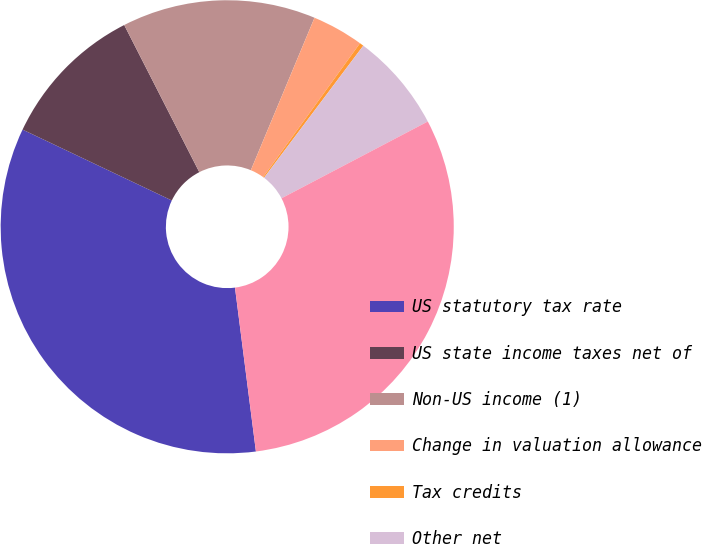Convert chart. <chart><loc_0><loc_0><loc_500><loc_500><pie_chart><fcel>US statutory tax rate<fcel>US state income taxes net of<fcel>Non-US income (1)<fcel>Change in valuation allowance<fcel>Tax credits<fcel>Other net<fcel>Effective rate<nl><fcel>34.08%<fcel>10.43%<fcel>13.81%<fcel>3.67%<fcel>0.29%<fcel>7.05%<fcel>30.67%<nl></chart> 